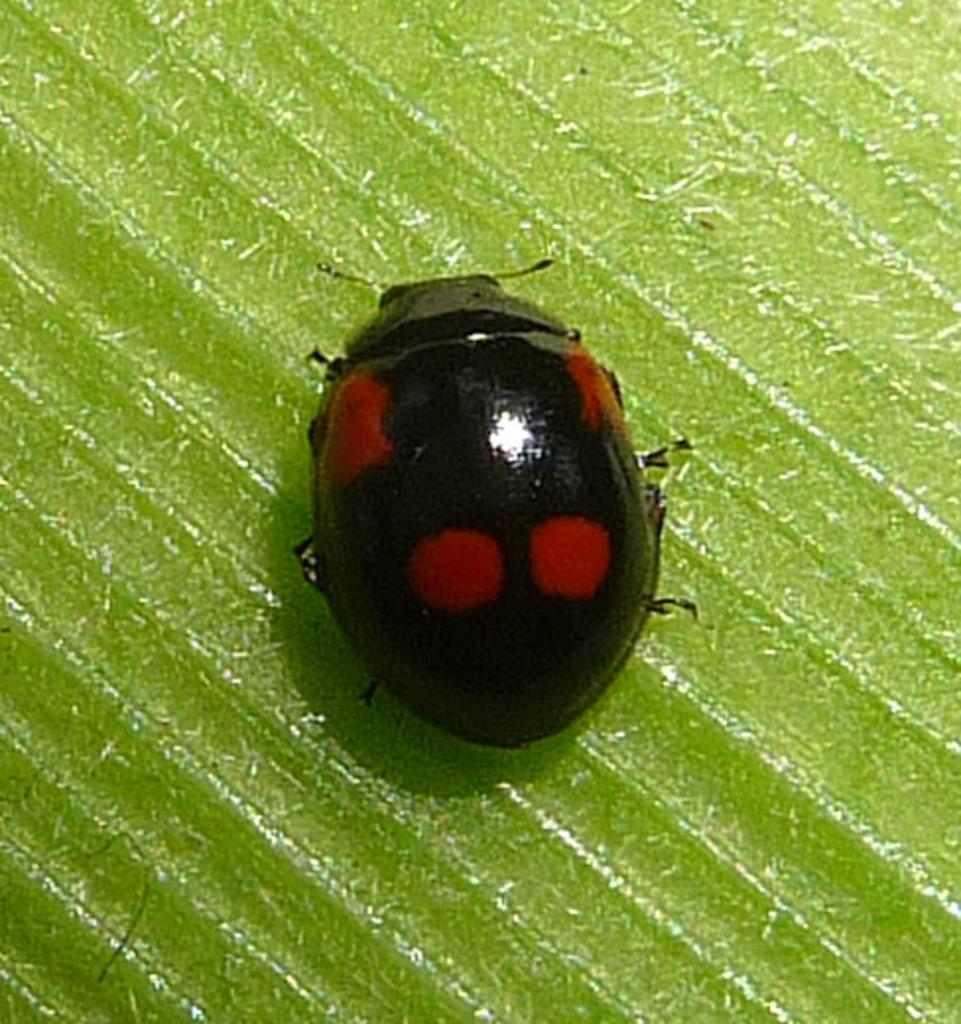What type of creature is present in the image? There is an insect in the image. What colors can be seen on the insect? The insect has red and black colors. What is the color of the background in the image? The background of the image is green. Where is the shade provided by the apple tree in the image? There is no apple tree or shade present in the image; it only features an insect with a green background. 